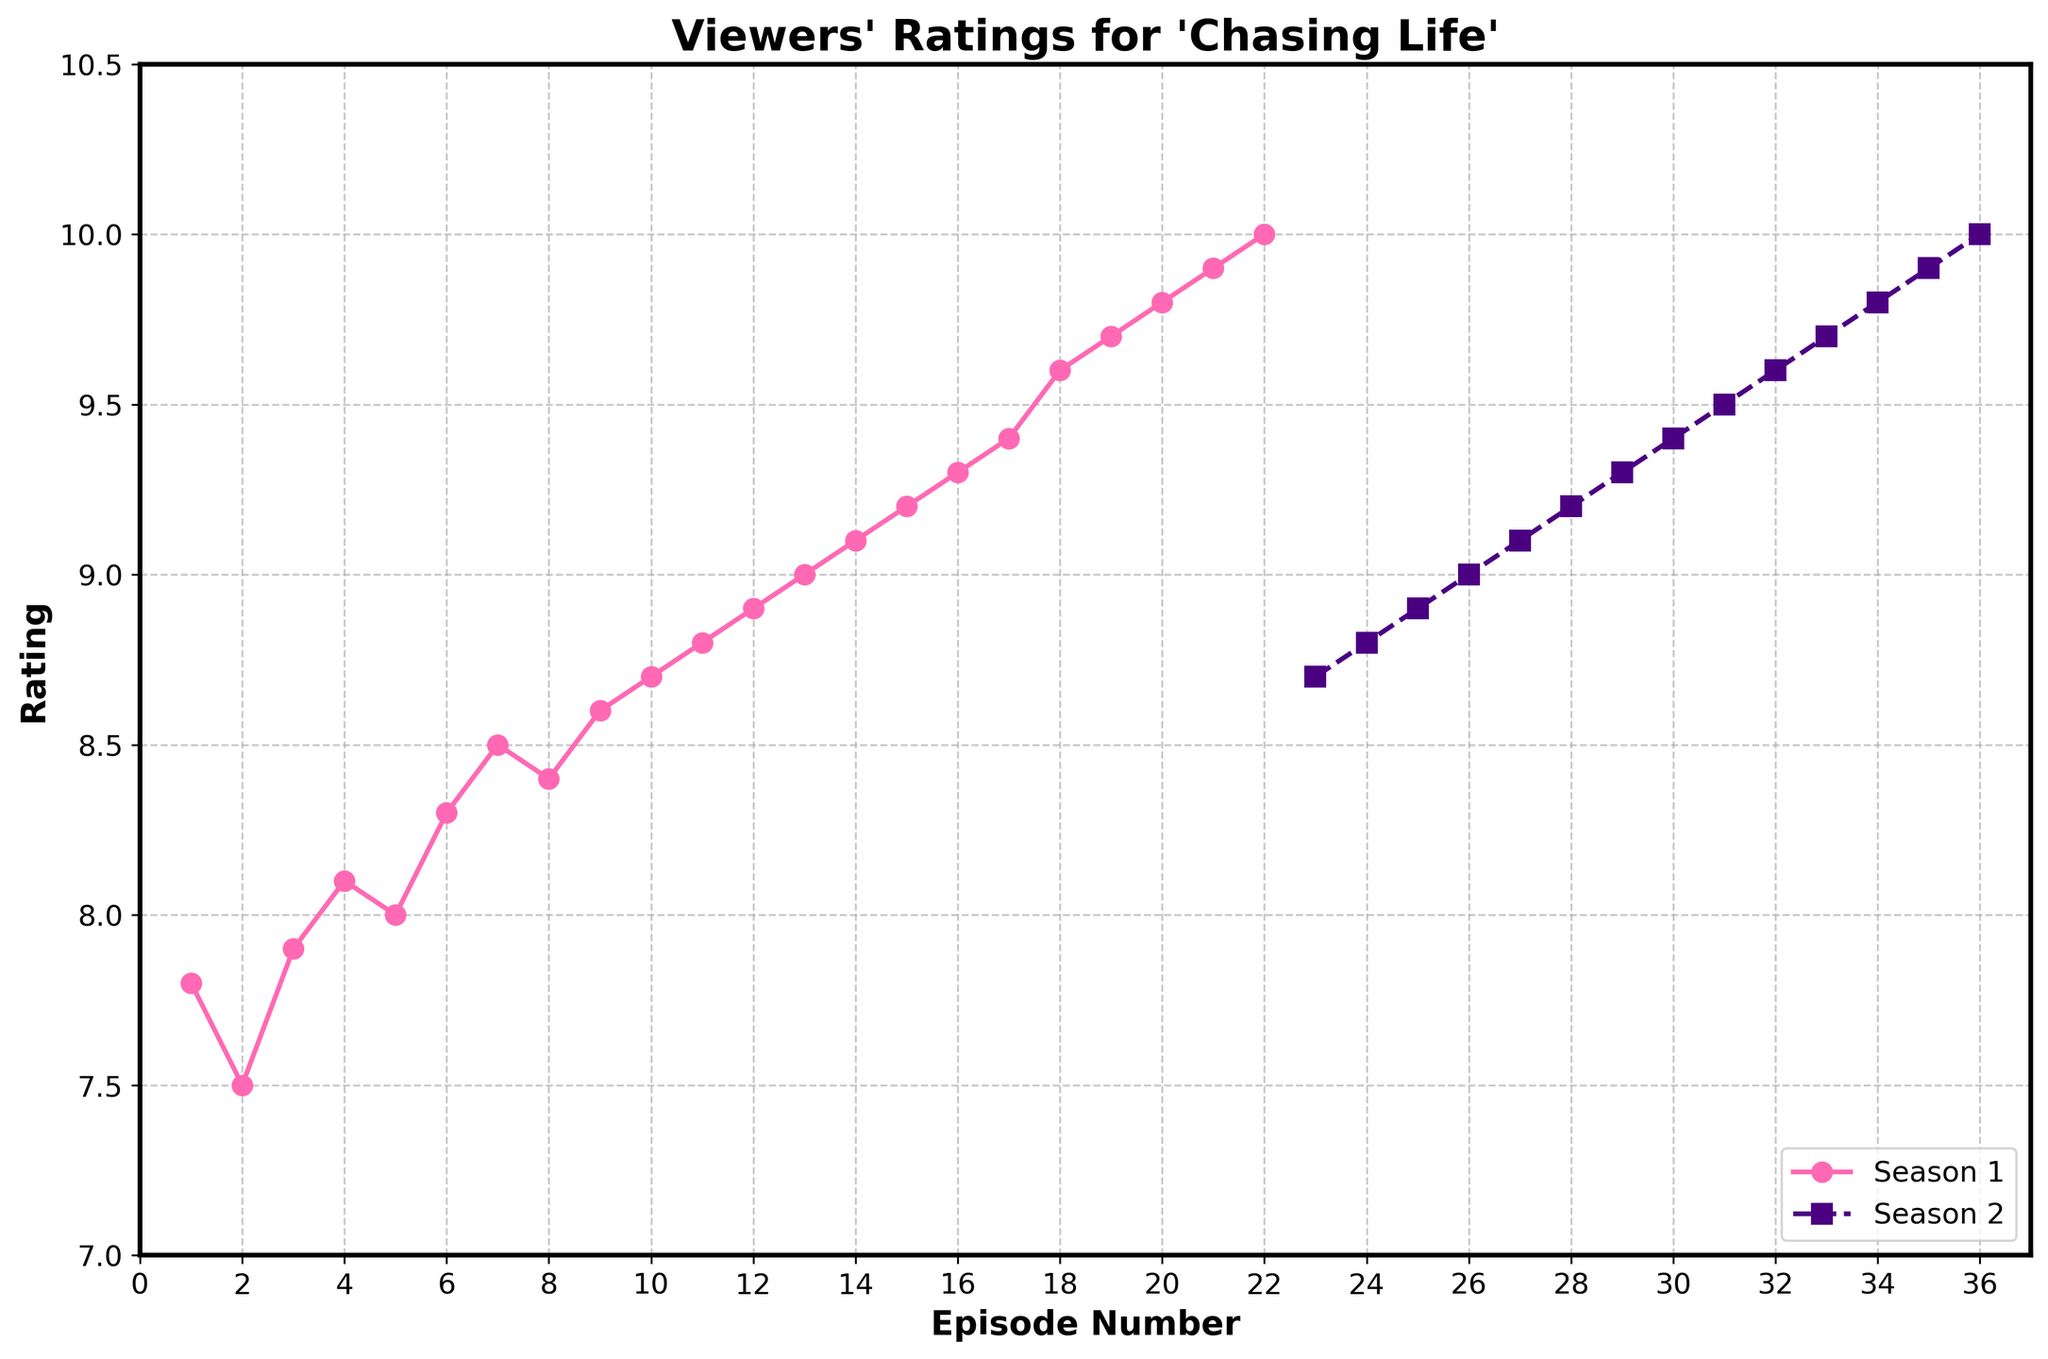How many episodes in total received a perfect rating of 10 in either season? First, verify which episodes received a rating of 10 by examining the chart. "As Long As We Both Shall Live" in Season 1 and "Finale" in Season 2 both received a 10. Thus, the total is 2 episodes.
Answer: 2 Which episode received the highest rating in Season 1, and what was that rating? Identify the peak of the Season 1 line on the graph. The highest rating in Season 1 is episode "As Long As We Both Shall Live" with a rating of 10.
Answer: 10 ("As Long As We Both Shall Live") On average, how did the ratings change from "Pilot" to "Finale" in each season? Calculate the average rating change in Season 1 by taking the difference from the first to the last episode: 10 - 7.8 = 2.2. For Season 2, the change is from 8.7 to 10, which is 1.3.
Answer: 2.2 (Season 1), 1.3 (Season 2) Compare the viewer ratings for the mid-season episodes (Episode 11 in Season 1 and Episode 18 in Season 2). Which one is higher? Check the ratings for these specific episodes. Episode 11 ("Next April") in Season 1 has a rating of 8.8. Episode 18 ("Sweet Sixteen") in Season 2 has a rating of 9.9. Thus, Sweet Sixteen is higher.
Answer: 9.9 (Episode 18, Season 2) What is the difference in ratings between the first episode and the last episode in Season 2? Look at the ratings for the first and last episodes of Season 2. The first episode, "A View from the Ledge," is 8.7, and the last episode, "Finale," is 10. The difference is 10 - 8.7 = 1.3.
Answer: 1.3 Which season exhibited a more consistent rating trend, and how can you determine this from the visual data? To determine consistency, observe the fluctuation of the ratings in each season. Season 1 has a more upward trend but changes slightly episode to episode. Season 2 shows fewer fluctuations with a steady increase. Therefore, Season 2 is more consistent.
Answer: Season 2 Are there episodes where the ratings between two consecutive episodes stayed the same? Look carefully at adjacent points on the line graph for both seasons. No consecutive episodes have the exact same rating; ratings change between episodes.
Answer: No What is the sum of the highest ratings for both seasons? Identify the highest rating in each season: "As Long As We Both Shall Live" in Season 1 is 10 and "Finale" in Season 2 is 10. Sum these values: 10 + 10 = 20.
Answer: 20 